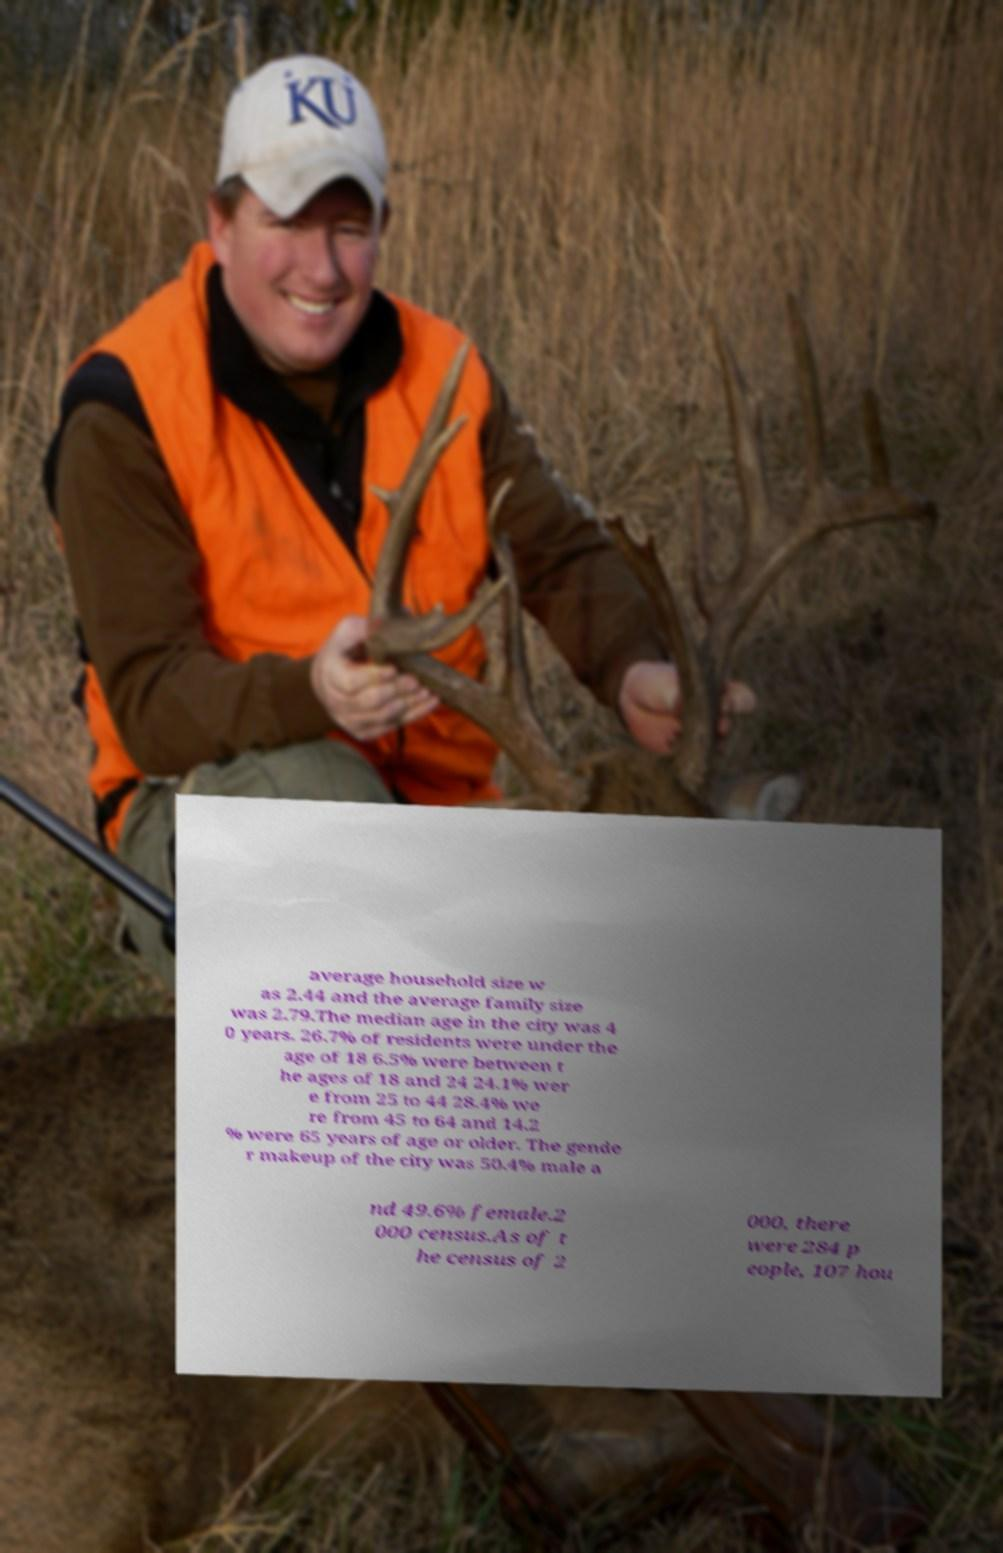Could you extract and type out the text from this image? average household size w as 2.44 and the average family size was 2.79.The median age in the city was 4 0 years. 26.7% of residents were under the age of 18 6.5% were between t he ages of 18 and 24 24.1% wer e from 25 to 44 28.4% we re from 45 to 64 and 14.2 % were 65 years of age or older. The gende r makeup of the city was 50.4% male a nd 49.6% female.2 000 census.As of t he census of 2 000, there were 284 p eople, 107 hou 